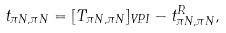<formula> <loc_0><loc_0><loc_500><loc_500>t _ { \pi N , \pi N } = [ T _ { \pi N , \pi N } ] _ { V P I } - t ^ { R } _ { \pi N , \pi N } ,</formula> 